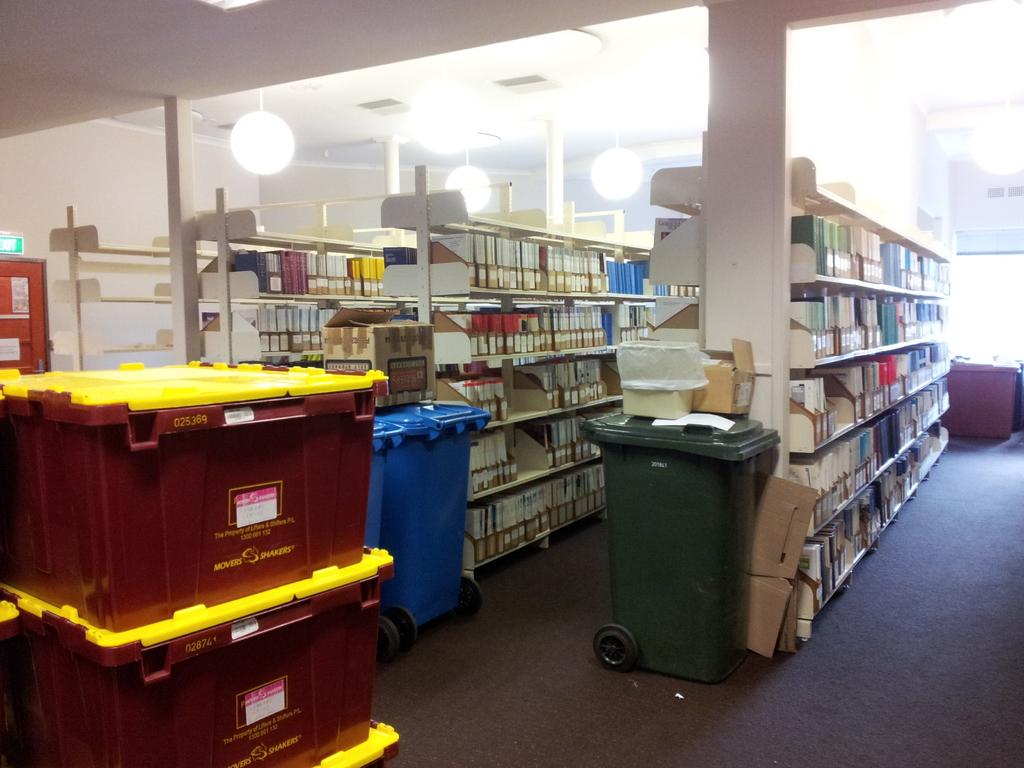What brand is on the box?
Make the answer very short. Movers shakers. 